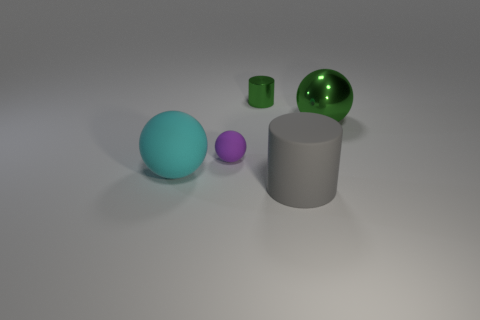Add 3 small metallic cylinders. How many objects exist? 8 Subtract all spheres. How many objects are left? 2 Add 2 big gray rubber things. How many big gray rubber things exist? 3 Subtract 0 red cylinders. How many objects are left? 5 Subtract all yellow rubber balls. Subtract all tiny purple matte balls. How many objects are left? 4 Add 4 shiny cylinders. How many shiny cylinders are left? 5 